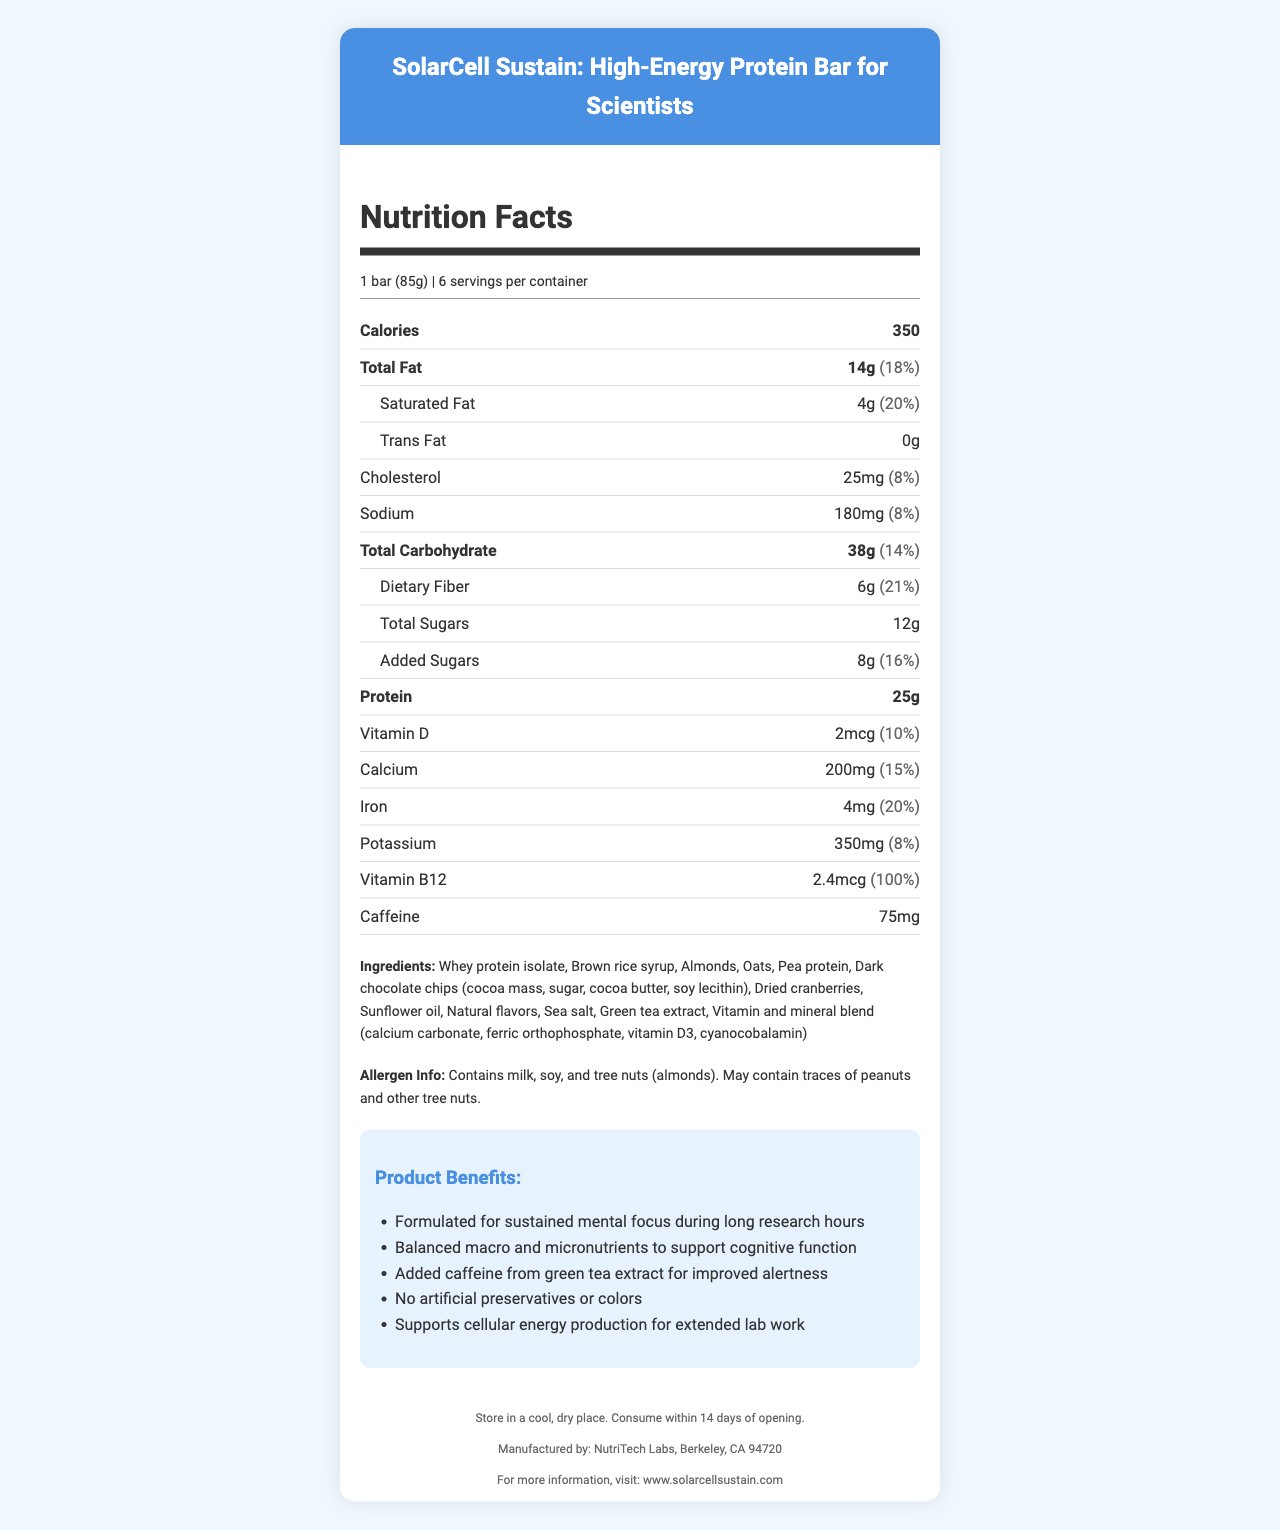what is the serving size? The serving size is indicated at the beginning of the document as "1 bar (85g)".
Answer: 1 bar (85g) how many calories are in one serving? Under the "Calories" section, it states "350".
Answer: 350 which nutrient has the highest daily value percentage? Among the listed nutrients, protein has the highest daily value percentage at 100%.
Answer: Protein how much caffeine is in the bar? Caffeine content is listed as "75mg" in the document.
Answer: 75mg what is the amount of dietary fiber per serving? The dietary fiber per serving is listed as 6g.
Answer: 6g which vitamin is present at 100% daily value? A. Vitamin D B. Calcium C. Vitamin B12 D. Iron The document lists Vitamin B12 at 100% daily value.
Answer: C which ingredient is not in the protein bar? A. Oats B. Pea protein C. Wheat D. Almonds Wheat is not mentioned in the list of ingredients.
Answer: C does the bar contain any allergens? (Yes/No) The allergen info section mentions that the bar contains milk, soy, and tree nuts (almonds), and may contain traces of peanuts and other tree nuts.
Answer: Yes describe the purpose of the solarcell sustain high-energy protein bar The marketing claims section highlights its purpose for mental focus, cognitive support, caffeine for alertness, and balanced nutrients.
Answer: It is formulated for sustained mental focus during long research hours, supports cognitive function, includes added caffeine for improved alertness, and comprises balanced macro and micronutrients. can the exact types of preservatives used in the bar be determined from the document? The document mentions "No artificial preservatives or colors" but does not specify the exact types of preservatives used, if any.
Answer: Not enough information what is the main ingredient of the bar? The list of ingredients starts with Whey protein isolate, indicating it is the main ingredient.
Answer: Whey protein isolate what is the amount of added sugars in the bar? The document states "Added Sugars" as 8g.
Answer: 8g who manufactures the solarcell sustain protein bar? The footer of the document states that NutriTech Labs, located in Berkeley, CA, manufactures the bar.
Answer: NutriTech Labs, Berkeley, CA 94720 how long can the bar be stored after opening? The storage instructions state that it should be consumed within 14 days of opening.
Answer: 14 days how much cholesterol is in one serving? The amount of cholesterol is listed as 25mg in one serving.
Answer: 25mg which ingredient provides natural caffeine in the bar? The ingredient list includes green tea extract, which is a natural caffeine source.
Answer: Green tea extract 